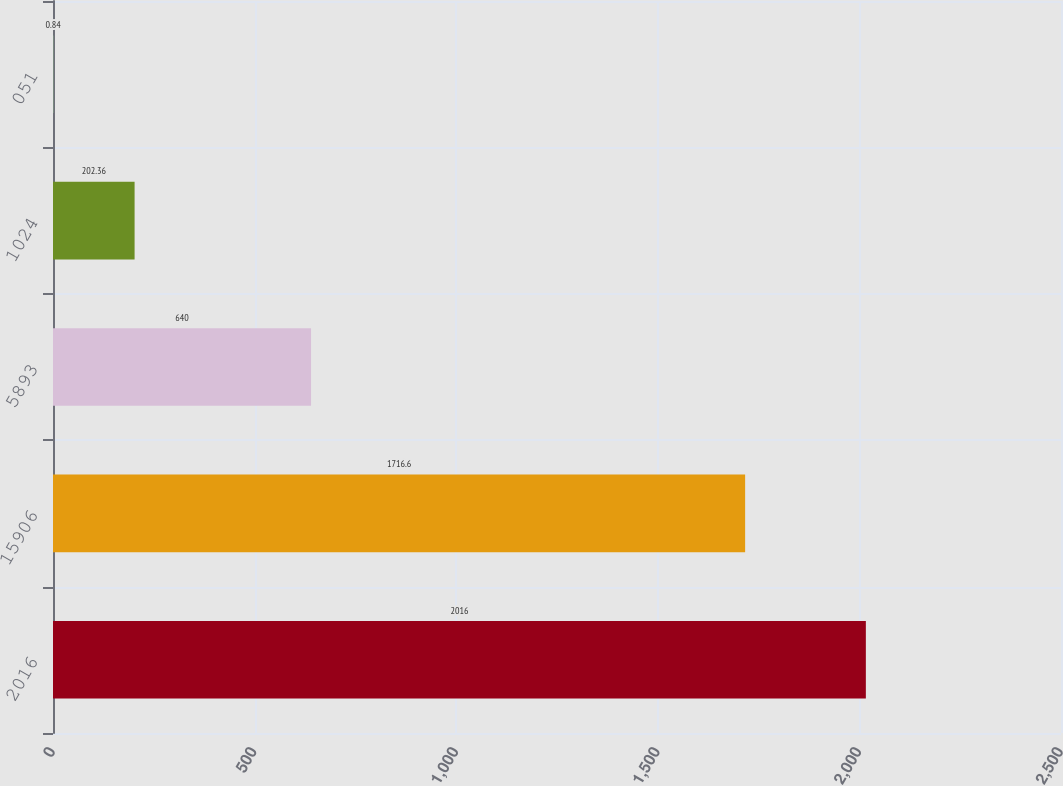Convert chart to OTSL. <chart><loc_0><loc_0><loc_500><loc_500><bar_chart><fcel>2016<fcel>15906<fcel>5893<fcel>1024<fcel>051<nl><fcel>2016<fcel>1716.6<fcel>640<fcel>202.36<fcel>0.84<nl></chart> 